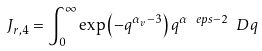<formula> <loc_0><loc_0><loc_500><loc_500>J _ { r , 4 } = \int _ { 0 } ^ { \infty } \exp \left ( - q ^ { \alpha _ { v } - 3 } \right ) q ^ { \alpha _ { \ } e p s - 2 } \ D { q }</formula> 